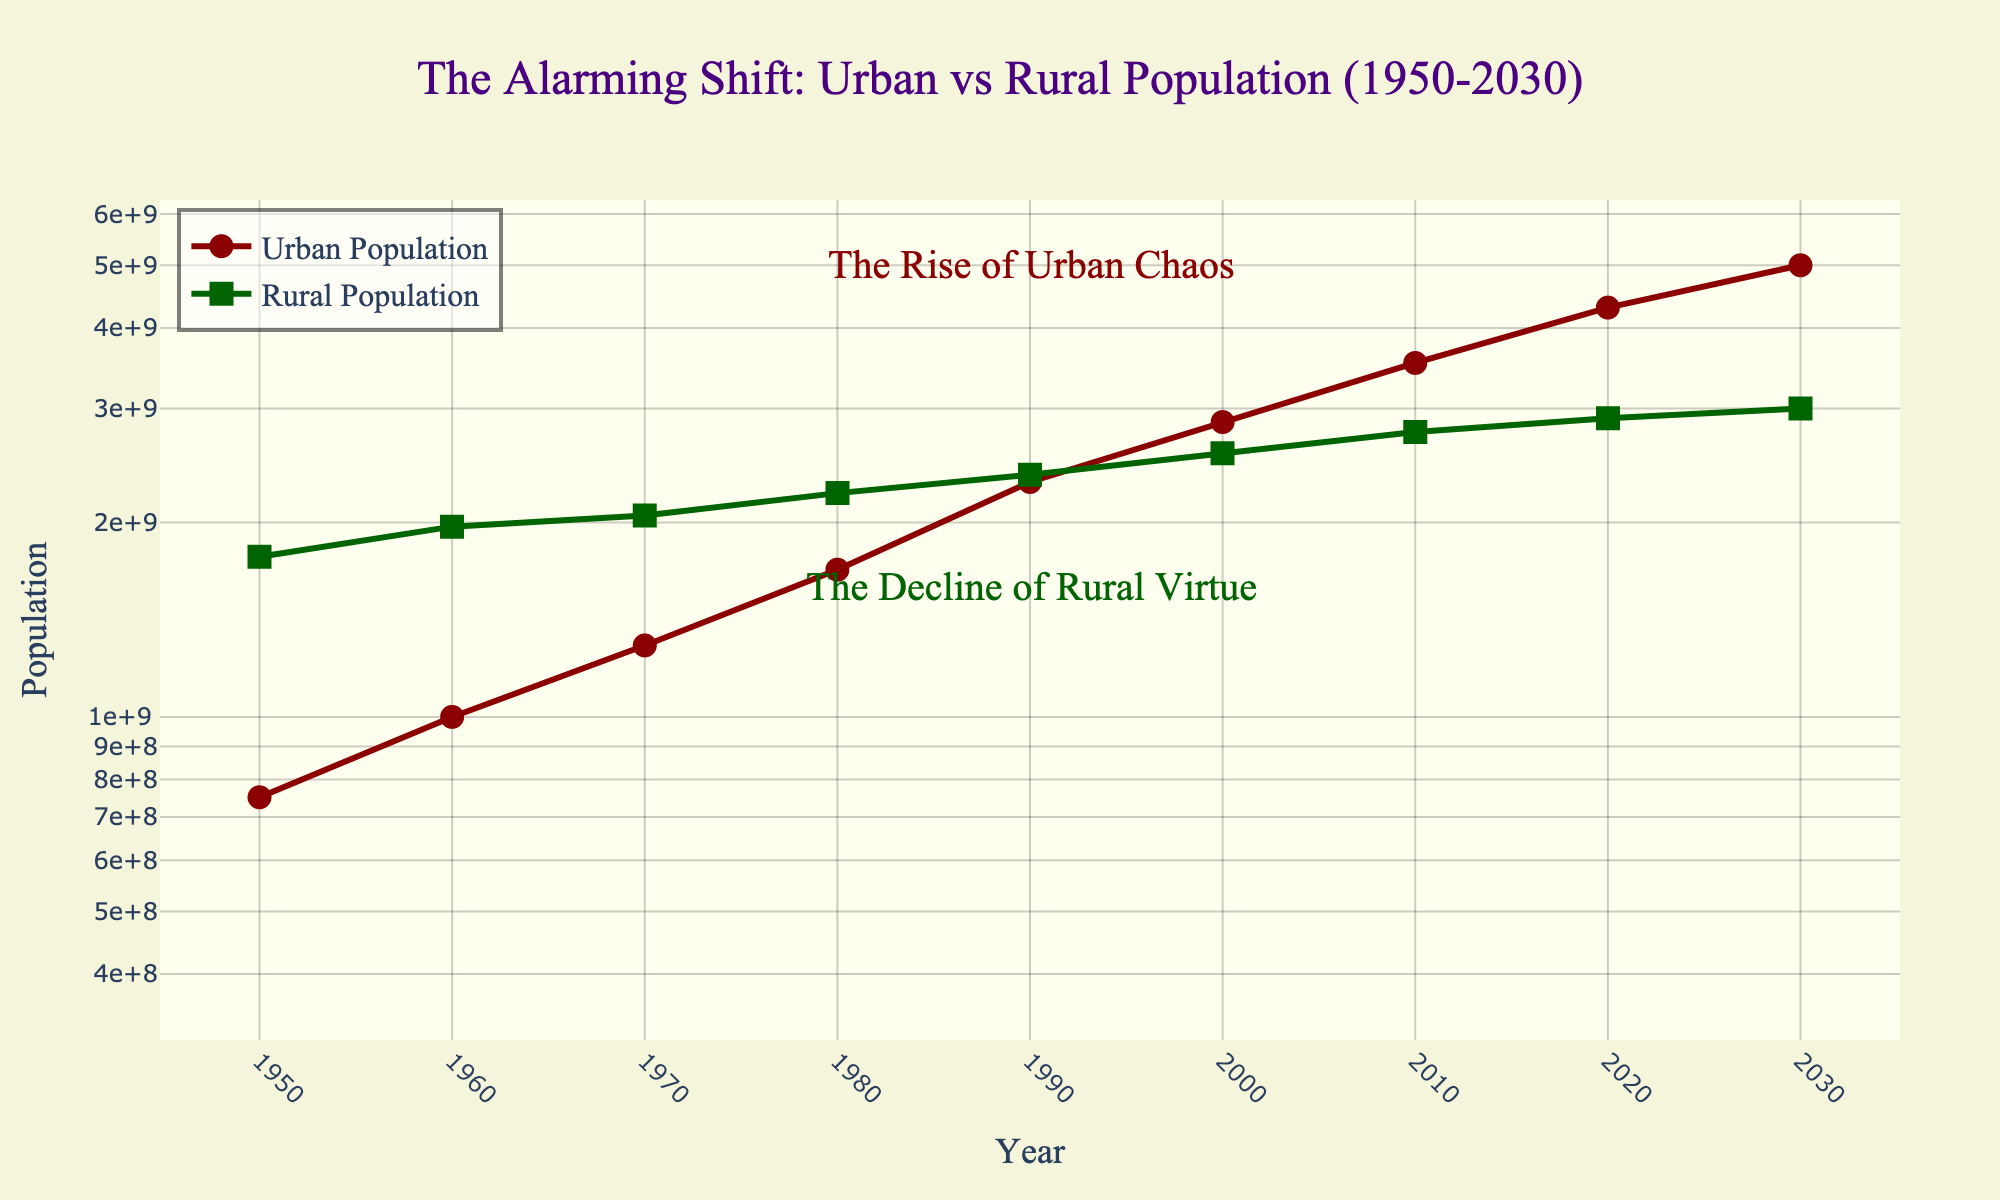What is the title of the plot? The title is located at the top center of the plot. It reads "The Alarming Shift: Urban vs Rural Population (1950-2030)"
Answer: The Alarming Shift: Urban vs Rural Population (1950-2030) What do the red and green lines represent? The red line represents the urban population, while the green line represents the rural population. This can be inferred from the legend located at the top left corner of the plot.
Answer: The red line is the urban population and the green line is the rural population What is the initial value of the urban population in 1950? By looking at the starting point of the red line in the year 1950 on the x-axis, and then tracing it to the y-axis, the value is approximately 751 million.
Answer: 751 million How has the rural population changed from 1950 to 2030? The green line on the plot shows a slight positive slope from 1950 to 2030, indicating a modest increase in rural population over time.
Answer: 123 million When did the urban population reach approximately 3.53 billion? According to the red line on the plot, the urban population reached approximately 3.53 billion in the year 2010.
Answer: 2010 How does the growth rate of the urban population compare to that of the rural population over the years? The urban population growth rate, as indicated by the slope of the red line, is significantly steeper over time compared to the rural population's green line which has a much gentler slope. This suggests a faster growth rate for the urban population.
Answer: Urban population grows faster When did the rural and urban populations appear to be closest in value? The plot shows that the rural and urban populations were closest in value around the year 2000, where their respective lines nearly intersect each other.
Answer: Around 2000 What year is annotated with "The Rise of Urban Chaos"? The annotation "The Rise of Urban Chaos" is placed around the year 1990 on the plot.
Answer: 1990 Considering the predicted data, what will the urban population be in 2030? The red line reaches the value of 5 billion on the y-axis in the year 2030 according to the plot.
Answer: 5 billion Between 1950 and 2020, how many times did the urban population double? From the red line in 1950 with approximately 751 million to 2020 with approximately 4.3 billion, the urban population has doubled roughly twice: once around the 1970s and again by 2000.
Answer: Twice 